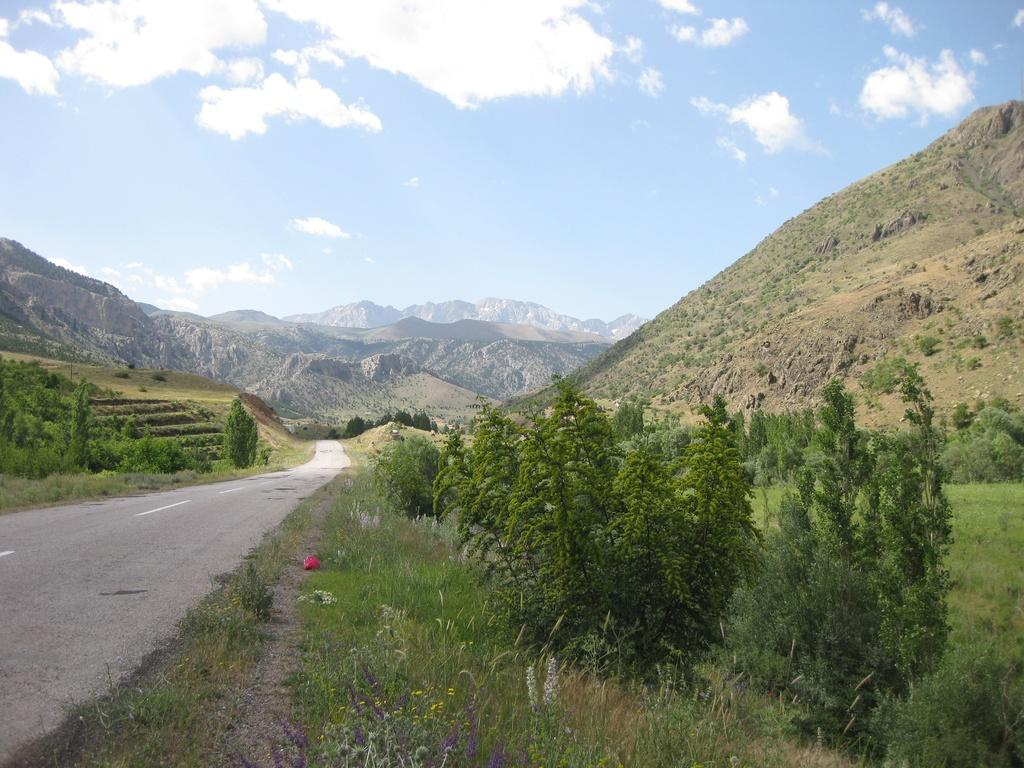What type of vegetation can be seen in the image? There is a group of trees in the image. What type of pathway is present in the image? There is a road in the image. What geographical feature is visible in the image? There is a hill in the image. What distant landforms can be seen in the image? There are mountains in the image. What is visible in the background of the image? The sky is visible in the background of the image. How would you describe the weather based on the sky's appearance? The sky appears to be cloudy in the image. How many boys are resting on the hill in the image? There are no boys present in the image; it features a group of trees, a road, a hill, mountains, and a cloudy sky. What type of lumber is being used to construct the mountains in the image? The mountains in the image are natural landforms and not constructed with lumber. 